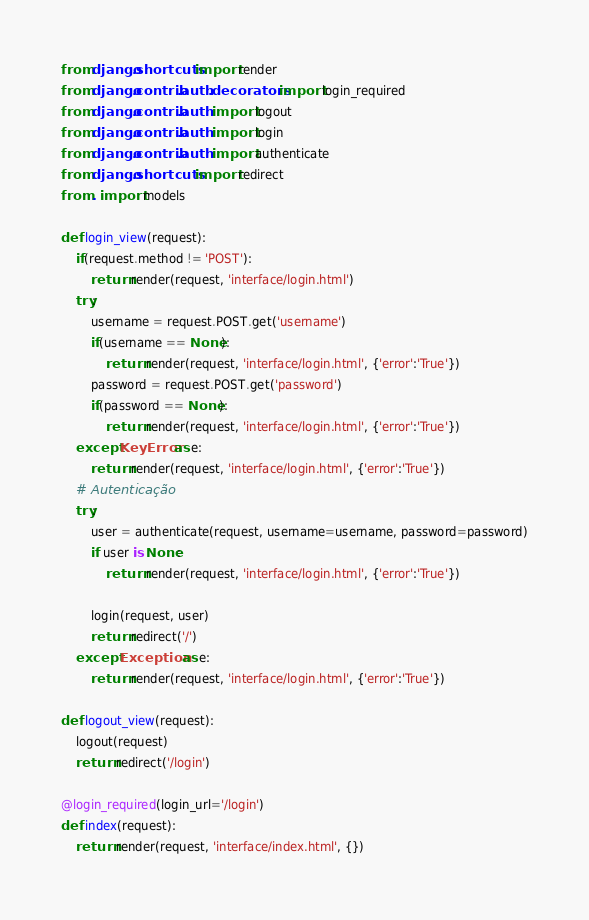Convert code to text. <code><loc_0><loc_0><loc_500><loc_500><_Python_>from django.shortcuts import render
from django.contrib.auth.decorators import login_required
from django.contrib.auth import logout
from django.contrib.auth import login
from django.contrib.auth import authenticate
from django.shortcuts import redirect
from . import models

def login_view(request):
    if(request.method != 'POST'):
        return render(request, 'interface/login.html')
    try:
        username = request.POST.get('username')
        if(username == None):
            return render(request, 'interface/login.html', {'error':'True'})
        password = request.POST.get('password')
        if(password == None):
            return render(request, 'interface/login.html', {'error':'True'})
    except KeyError as e:
        return render(request, 'interface/login.html', {'error':'True'})
    # Autenticação
    try:
        user = authenticate(request, username=username, password=password)
        if user is None:
            return render(request, 'interface/login.html', {'error':'True'})
       
        login(request, user)
        return redirect('/')
    except Exception as e:
        return render(request, 'interface/login.html', {'error':'True'})

def logout_view(request):
    logout(request)
    return redirect('/login')

@login_required(login_url='/login')
def index(request):
    return render(request, 'interface/index.html', {})</code> 